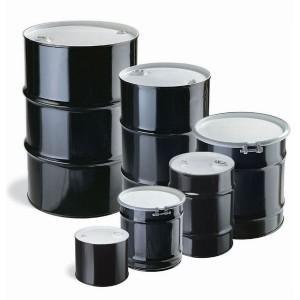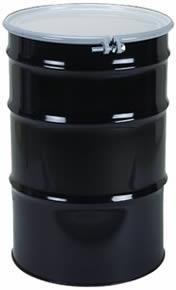The first image is the image on the left, the second image is the image on the right. Examine the images to the left and right. Is the description "The right image contains exactly one black barrel." accurate? Answer yes or no. Yes. The first image is the image on the left, the second image is the image on the right. For the images shown, is this caption "The image on the right has a single canister while the image on the left has six." true? Answer yes or no. Yes. 